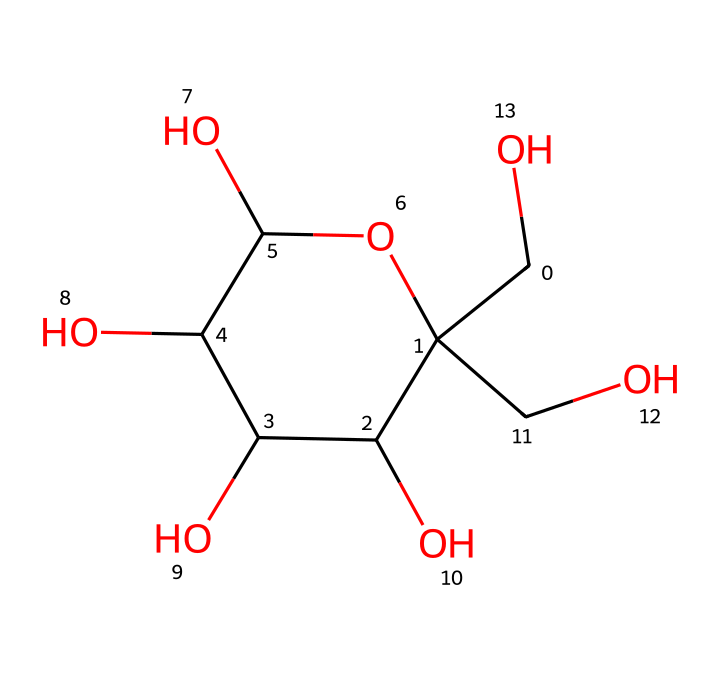What is the molecular formula of fructose? To determine the molecular formula, count the number of each type of atom in the chemical structure. In this case, there are 6 carbon atoms, 12 hydrogen atoms, and 6 oxygen atoms, which leads to the formula C6H12O6.
Answer: C6H12O6 How many hydroxyl (-OH) groups are present in fructose? By examining the chemical structure, you can identify the hydroxyl groups attached to the carbon backbone. There are 5 hydroxyl groups in fructose, which can be seen as the -OH attachments on the carbon atoms.
Answer: 5 Is fructose a simple sugar or a complex carbohydrate? Fructose is classified as a monosaccharide, which is a simple sugar. This classification is determined by its molecular structure, which consists of a single sugar unit.
Answer: simple sugar What is the significance of fructose in sports performance gels? Fructose is often used in sports performance gels as a rapid source of energy, allowing athletes to quickly replenish glycogen stores during exercise. Its chemistry allows for fast absorption, providing readily available energy.
Answer: energy source What type of carbohydrate is fructose classified as? Fructose is classified as a monosaccharide, which is the most basic form of carbohydrate, characterized by its single sugar unit. This classification determines its role and effectiveness in energy metabolism.
Answer: monosaccharide How does the structure of fructose affect its sweetness compared to glucose? The configuration of fructose, including its carbon arrangement and functional groups, makes it sweeter than glucose. This is assessed through sensory evaluation and studies on sweetness perception.
Answer: sweeter than glucose 